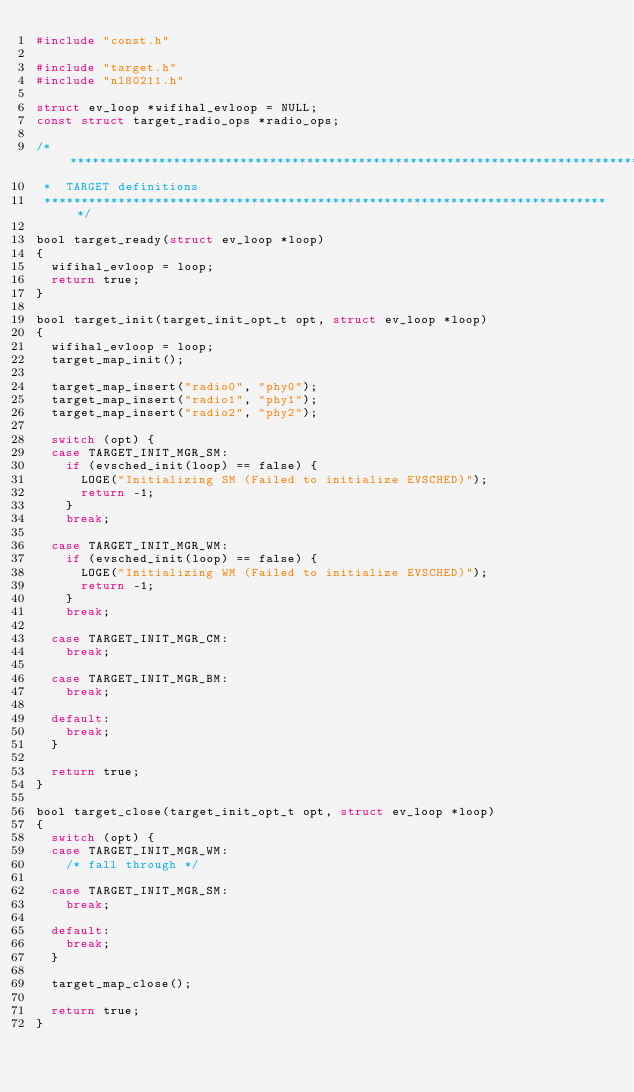Convert code to text. <code><loc_0><loc_0><loc_500><loc_500><_C_>#include "const.h"

#include "target.h"
#include "nl80211.h"

struct ev_loop *wifihal_evloop = NULL;
const struct target_radio_ops *radio_ops;

/******************************************************************************
 *  TARGET definitions
 *****************************************************************************/

bool target_ready(struct ev_loop *loop)
{
	wifihal_evloop = loop;
	return true;
}

bool target_init(target_init_opt_t opt, struct ev_loop *loop)
{
	wifihal_evloop = loop;
	target_map_init();

	target_map_insert("radio0", "phy0");
	target_map_insert("radio1", "phy1");
	target_map_insert("radio2", "phy2");

	switch (opt) {
	case TARGET_INIT_MGR_SM:
		if (evsched_init(loop) == false) {
			LOGE("Initializing SM (Failed to initialize EVSCHED)");
			return -1;
		}
		break;

	case TARGET_INIT_MGR_WM:
		if (evsched_init(loop) == false) {
			LOGE("Initializing WM (Failed to initialize EVSCHED)");
			return -1;
		}
		break;

	case TARGET_INIT_MGR_CM:
		break;

	case TARGET_INIT_MGR_BM:
		break;

	default:
		break;
	}

	return true;
}

bool target_close(target_init_opt_t opt, struct ev_loop *loop)
{
	switch (opt) {
	case TARGET_INIT_MGR_WM:
		/* fall through */

	case TARGET_INIT_MGR_SM:
		break;

	default:
		break;
	}

	target_map_close();

	return true;
}
</code> 